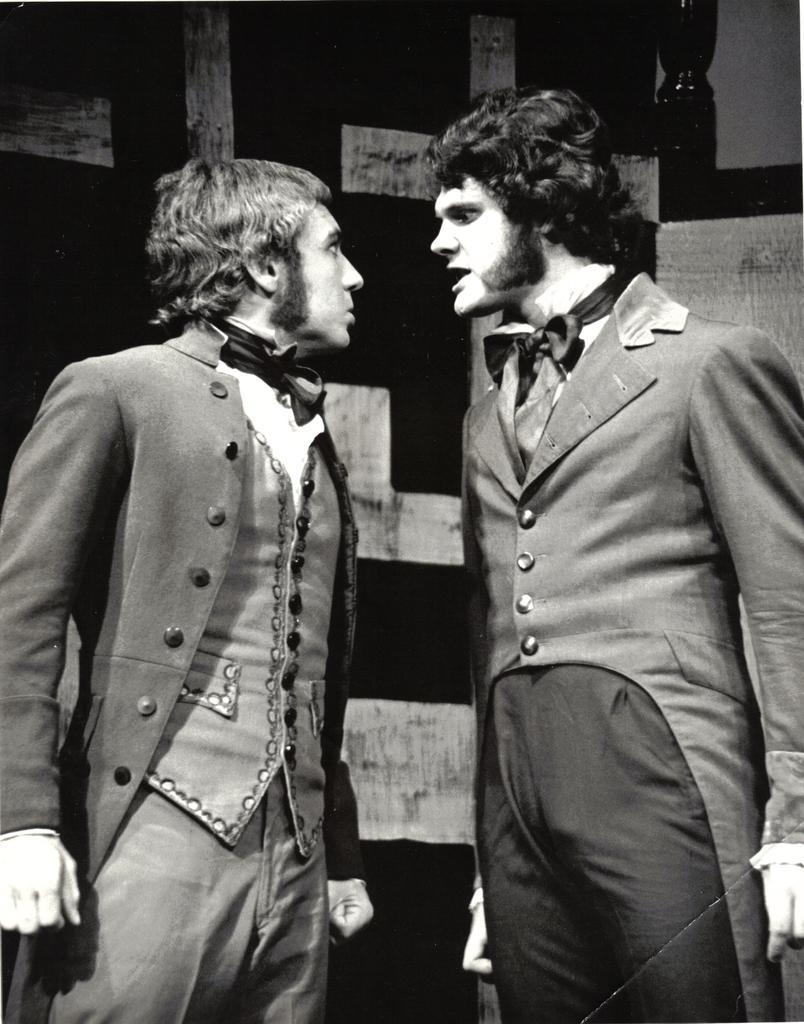In one or two sentences, can you explain what this image depicts? In this image we can see two people standing. They are wearing jackets. In the background there is a wall. 